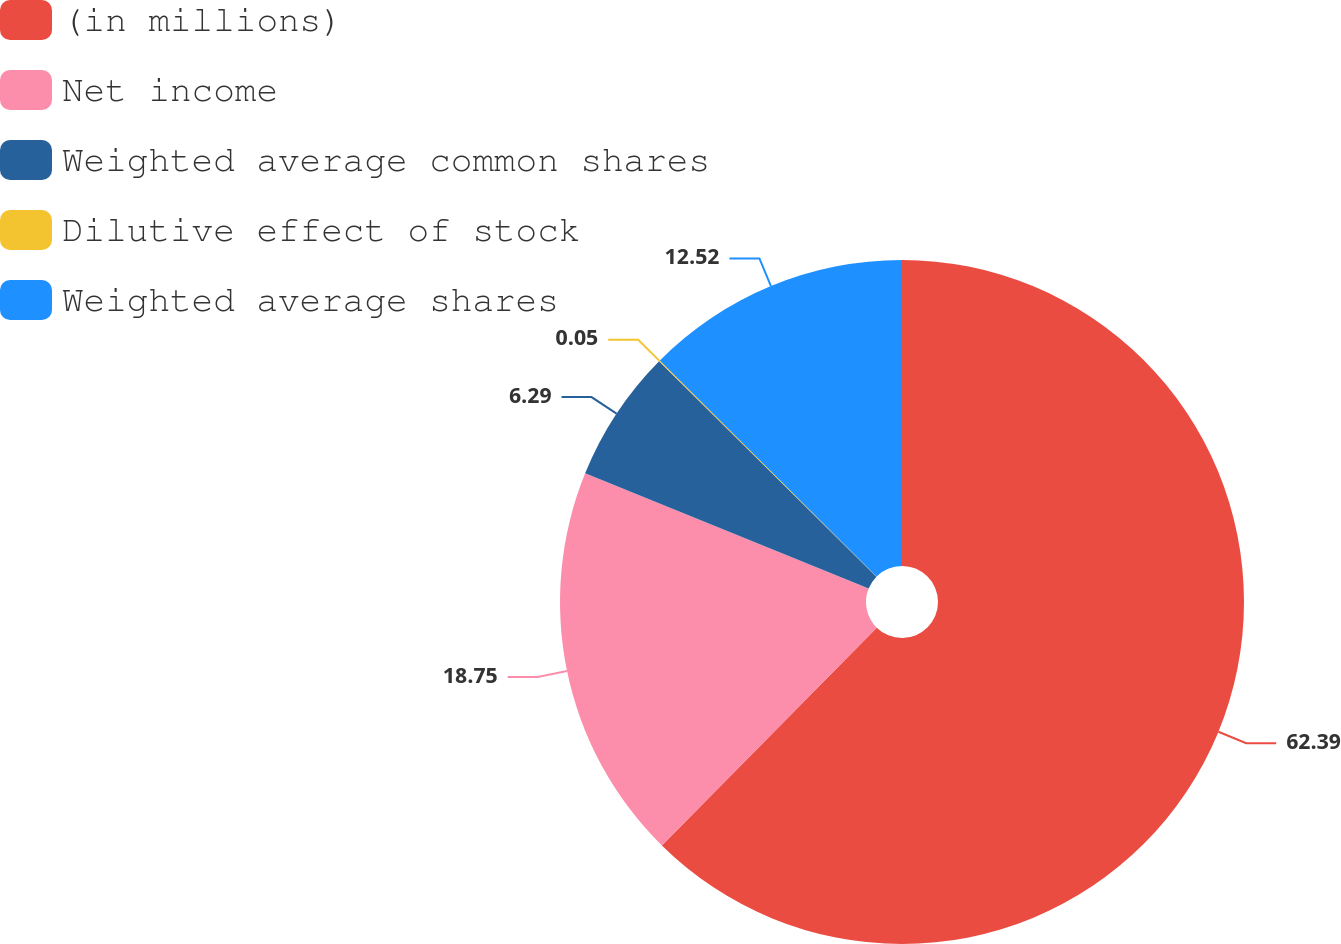<chart> <loc_0><loc_0><loc_500><loc_500><pie_chart><fcel>(in millions)<fcel>Net income<fcel>Weighted average common shares<fcel>Dilutive effect of stock<fcel>Weighted average shares<nl><fcel>62.39%<fcel>18.75%<fcel>6.29%<fcel>0.05%<fcel>12.52%<nl></chart> 